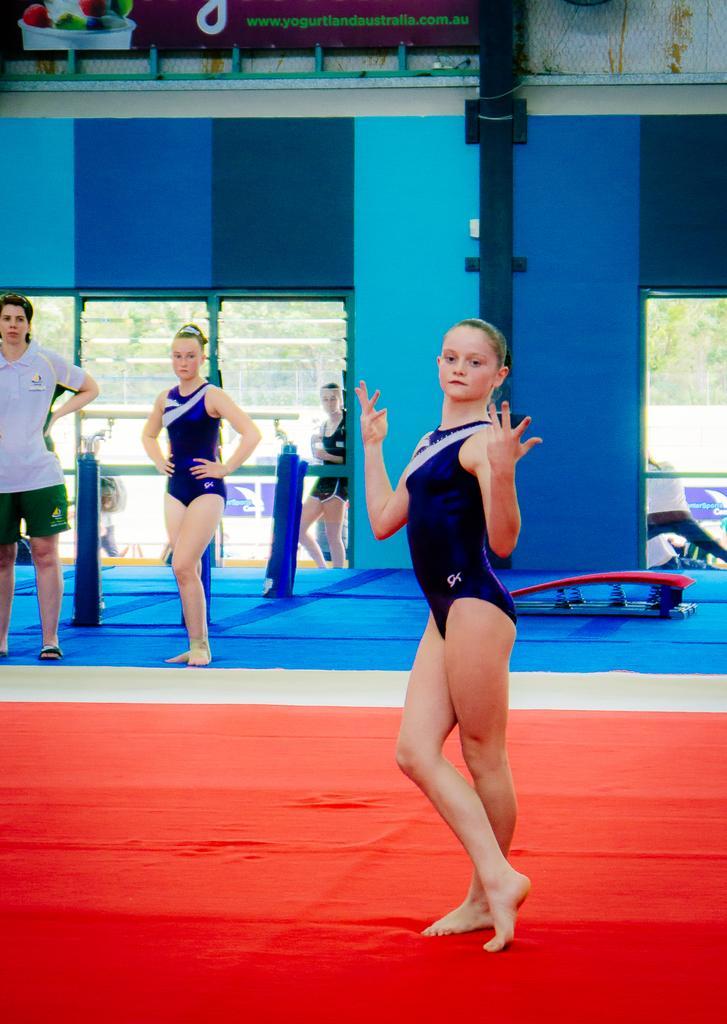In one or two sentences, can you explain what this image depicts? In this image there is a girl standing on the floor. There is a carpet on the floor. To the left there is a man and a woman standing. Behind them there is a wall. There are glass doors to the wall. Behind the door there is a girl standing. At the top there is a board. There are pictures and text on the board. Behind the girl there is an object on the floor. Outside the wall there are trees. 